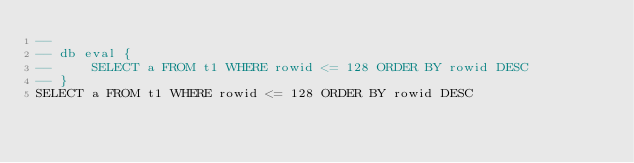<code> <loc_0><loc_0><loc_500><loc_500><_SQL_>-- 
-- db eval {
--     SELECT a FROM t1 WHERE rowid <= 128 ORDER BY rowid DESC
-- }
SELECT a FROM t1 WHERE rowid <= 128 ORDER BY rowid DESC</code> 